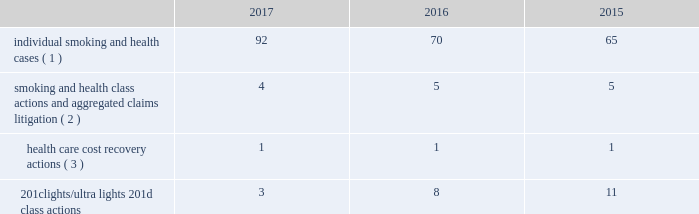10-k altria ar release tuesday , february 27 , 2018 10:00pm andra design llc verdicts have been appealed , there remains a risk that such relief may not be obtainable in all cases .
This risk has been substantially reduced given that 47 states and puerto rico limit the dollar amount of bonds or require no bond at all .
As discussed below , however , tobacco litigation plaintiffs have challenged the constitutionality of florida 2019s bond cap statute in several cases and plaintiffs may challenge state bond cap statutes in other jurisdictions as well .
Such challenges may include the applicability of state bond caps in federal court .
States , including florida , may also seek to repeal or alter bond cap statutes through legislation .
Although altria group , inc .
Cannot predict the outcome of such challenges , it is possible that the consolidated results of operations , cash flows or financial position of altria group , inc. , or one or more of its subsidiaries , could be materially affected in a particular fiscal quarter or fiscal year by an unfavorable outcome of one or more such challenges .
Altria group , inc .
And its subsidiaries record provisions in the consolidated financial statements for pending litigation when they determine that an unfavorable outcome is probable and the amount of the loss can be reasonably estimated .
At the present time , while it is reasonably possible that an unfavorable outcome in a case may occur , except to the extent discussed elsewhere in this note 18 .
Contingencies : ( i ) management has concluded that it is not probable that a loss has been incurred in any of the pending tobacco-related cases ; ( ii ) management is unable to estimate the possible loss or range of loss that could result from an unfavorable outcome in any of the pending tobacco-related cases ; and ( iii ) accordingly , management has not provided any amounts in the consolidated financial statements for unfavorable outcomes , if any .
Litigation defense costs are expensed as incurred .
Altria group , inc .
And its subsidiaries have achieved substantial success in managing litigation .
Nevertheless , litigation is subject to uncertainty and significant challenges remain .
It is possible that the consolidated results of operations , cash flows or financial position of altria group , inc. , or one or more of its subsidiaries , could be materially affected in a particular fiscal quarter or fiscal year by an unfavorable outcome or settlement of certain pending litigation .
Altria group , inc .
And each of its subsidiaries named as a defendant believe , and each has been so advised by counsel handling the respective cases , that it has valid defenses to the litigation pending against it , as well as valid bases for appeal of adverse verdicts .
Each of the companies has defended , and will continue to defend , vigorously against litigation challenges .
However , altria group , inc .
And its subsidiaries may enter into settlement discussions in particular cases if they believe it is in the best interests of altria group , inc .
To do so .
Overview of altria group , inc .
And/or pm usa tobacco- related litigation types and number of cases : claims related to tobacco products generally fall within the following categories : ( i ) smoking and health cases alleging personal injury brought on behalf of individual plaintiffs ; ( ii ) smoking and health cases primarily alleging personal injury or seeking court-supervised programs for ongoing medical monitoring and purporting to be brought on behalf of a class of individual plaintiffs , including cases in which the aggregated claims of a number of individual plaintiffs are to be tried in a single proceeding ; ( iii ) health care cost recovery cases brought by governmental ( both domestic and foreign ) plaintiffs seeking reimbursement for health care expenditures allegedly caused by cigarette smoking and/or disgorgement of profits ; ( iv ) class action suits alleging that the uses of the terms 201clights 201d and 201cultra lights 201d constitute deceptive and unfair trade practices , common law or statutory fraud , unjust enrichment , breach of warranty or violations of the racketeer influenced and corrupt organizations act ( 201crico 201d ) ; and ( v ) other tobacco-related litigation described below .
Plaintiffs 2019 theories of recovery and the defenses raised in pending smoking and health , health care cost recovery and 201clights/ultra lights 201d cases are discussed below .
The table below lists the number of certain tobacco-related cases pending in the united states against pm usa and , in some instances , altria group , inc .
As of december 31 , 2017 , 2016 and .
( 1 ) does not include 2414 cases brought by flight attendants seeking compensatory damages for personal injuries allegedly caused by exposure to environmental tobacco smoke ( 201cets 201d ) .
The flight attendants allege that they are members of an ets smoking and health class action in florida , which was settled in 1997 ( broin ) .
The terms of the court-approved settlement in that case allowed class members to file individual lawsuits seeking compensatory damages , but prohibited them from seeking punitive damages .
Also , does not include individual smoking and health cases brought by or on behalf of plaintiffs in florida state and federal courts following the decertification of the engle case ( discussed below in smoking and health litigation - engle class action ) .
( 2 ) includes as one case the 30 civil actions that were to be tried in six consolidated trials in west virginia ( in re : tobacco litigation ) .
Pm usa is a defendant in nine of the 30 cases .
The parties have agreed to resolve the cases for an immaterial amount and have so notified the court .
( 3 ) see health care cost recovery litigation - federal government 2019s lawsuit below .
International tobacco-related cases : as of january 29 , 2018 , pm usa is a named defendant in 10 health care cost recovery actions in canada , eight of which also name altria group , inc .
As a defendant .
Pm usa and altria group , inc .
Are also named defendants in seven smoking and health class actions filed in various canadian provinces .
See guarantees and other similar matters below for a discussion of the distribution agreement between altria group , inc .
And pmi that provides for indemnities for certain liabilities concerning tobacco products. .
What are the total number of pending tobacco-related cases in united states in 2017? 
Computations: (((92 + 4) + 1) + 3)
Answer: 100.0. 